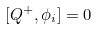Convert formula to latex. <formula><loc_0><loc_0><loc_500><loc_500>[ Q ^ { + } , \phi _ { i } ] = 0</formula> 